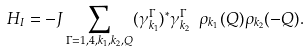Convert formula to latex. <formula><loc_0><loc_0><loc_500><loc_500>H _ { I } = - J \sum _ { \Gamma = 1 , 4 , k _ { 1 } , k _ { 2 } , Q } ( \gamma ^ { \Gamma } _ { k _ { 1 } } ) ^ { * } \gamma ^ { \Gamma } _ { k _ { 2 } } \ \rho _ { k _ { 1 } } ( Q ) \rho _ { k _ { 2 } } ( - Q ) .</formula> 